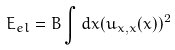Convert formula to latex. <formula><loc_0><loc_0><loc_500><loc_500>E _ { e l } = B \int d x ( u _ { x , x } ( x ) ) ^ { 2 }</formula> 